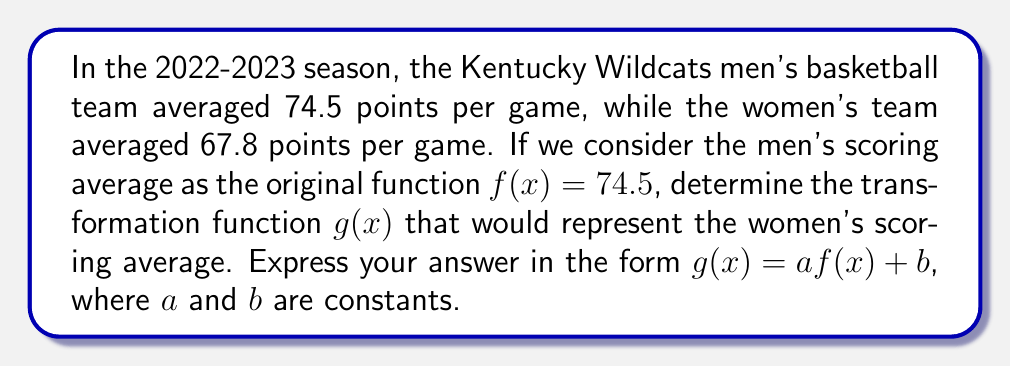Provide a solution to this math problem. To solve this problem, we need to find the scaling factor $a$ and the vertical translation $b$ that transform the men's scoring average into the women's scoring average. Let's approach this step-by-step:

1) The original function representing the men's scoring average is:
   $f(x) = 74.5$

2) We need to find $g(x)$ such that:
   $g(x) = af(x) + b = 67.8$

3) To find $a$, we calculate the ratio of the women's average to the men's average:
   $a = \frac{67.8}{74.5} \approx 0.91$

4) This means that $g(x) = 0.91f(x)$

5) However, this alone doesn't give us exactly 67.8. We need to add a vertical translation $b$:
   $0.91 \cdot 74.5 = 67.795$

6) To get from 67.795 to 67.8, we need to add 0.005:
   $b = 67.8 - 67.795 = 0.005$

Therefore, the transformation function $g(x)$ that represents the women's scoring average in terms of the men's scoring average is:

$g(x) = 0.91f(x) + 0.005$
Answer: $g(x) = 0.91f(x) + 0.005$ 